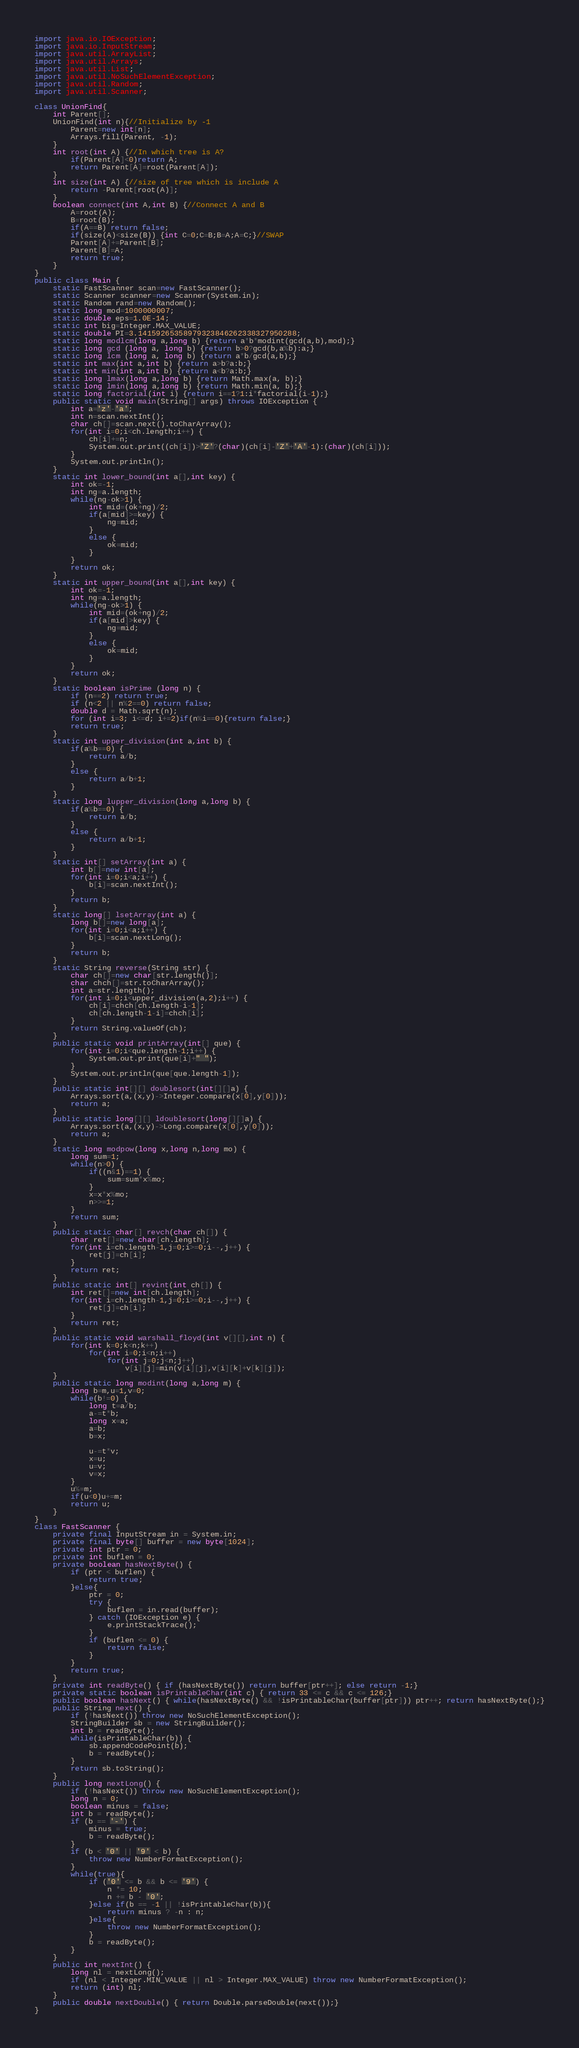<code> <loc_0><loc_0><loc_500><loc_500><_Java_>import java.io.IOException;
import java.io.InputStream;
import java.util.ArrayList;
import java.util.Arrays;
import java.util.List;
import java.util.NoSuchElementException;
import java.util.Random;
import java.util.Scanner;

class UnionFind{
	int Parent[];
	UnionFind(int n){//Initialize by -1
		Parent=new int[n];
		Arrays.fill(Parent, -1);
	}
	int root(int A) {//In which tree is A?
		if(Parent[A]<0)return A;
		return Parent[A]=root(Parent[A]);
	}
	int size(int A) {//size of tree which is include A
		return -Parent[root(A)];
	}
	boolean connect(int A,int B) {//Connect A and B
		A=root(A);
		B=root(B);
		if(A==B) return false;
		if(size(A)<size(B)) {int C=0;C=B;B=A;A=C;}//SWAP
		Parent[A]+=Parent[B];
		Parent[B]=A;
		return true;
	}
}
public class Main {
	static FastScanner scan=new FastScanner();
	static Scanner scanner=new Scanner(System.in);
	static Random rand=new Random();
	static long mod=1000000007;
	static double eps=1.0E-14;
	static int big=Integer.MAX_VALUE;
	static double PI=3.14159265358979323846262338327950288;
	static long modlcm(long a,long b) {return a*b*modint(gcd(a,b),mod);}
	static long gcd (long a, long b) {return b>0?gcd(b,a%b):a;}
	static long lcm (long a, long b) {return a*b/gcd(a,b);}
	static int max(int a,int b) {return a>b?a:b;}
	static int min(int a,int b) {return a<b?a:b;}
	static long lmax(long a,long b) {return Math.max(a, b);}
	static long lmin(long a,long b) {return Math.min(a, b);}
	static long factorial(int i) {return i==1?1:i*factorial(i-1);}
	public static void main(String[] args) throws IOException {
		int a='z'-'a';
		int n=scan.nextInt();
		char ch[]=scan.next().toCharArray();
		for(int i=0;i<ch.length;i++) {
			ch[i]+=n;
			System.out.print((ch[i])>'Z'?(char)(ch[i]-'Z'+'A'-1):(char)(ch[i]));
		}
		System.out.println();
	}
	static int lower_bound(int a[],int key) {
		int ok=-1;
		int ng=a.length;
		while(ng-ok>1) {
			int mid=(ok+ng)/2;
			if(a[mid]>=key) {
				ng=mid;
			}
			else {
				ok=mid;
			}
		}
		return ok;
	}
	static int upper_bound(int a[],int key) {
		int ok=-1;
		int ng=a.length;
		while(ng-ok>1) {
			int mid=(ok+ng)/2;
			if(a[mid]>key) {
				ng=mid;
			}
			else {
				ok=mid;
			}
		}
		return ok;
	}
	static boolean isPrime (long n) {
		if (n==2) return true;
		if (n<2 || n%2==0) return false;
		double d = Math.sqrt(n);
		for (int i=3; i<=d; i+=2)if(n%i==0){return false;}
		return true;
	}
	static int upper_division(int a,int b) {
		if(a%b==0) {
			return a/b;
		}
		else {
			return a/b+1;
		}
	}
	static long lupper_division(long a,long b) {
		if(a%b==0) {
			return a/b;
		}
		else {
			return a/b+1;
		}
	}
	static int[] setArray(int a) {
		int b[]=new int[a];
		for(int i=0;i<a;i++) {
			b[i]=scan.nextInt();
		}
		return b;
	}
	static long[] lsetArray(int a) {
		long b[]=new long[a];
		for(int i=0;i<a;i++) {
			b[i]=scan.nextLong();
		}
		return b;
	}
	static String reverse(String str) {
		char ch[]=new char[str.length()];
		char chch[]=str.toCharArray();
		int a=str.length();
		for(int i=0;i<upper_division(a,2);i++) {
			ch[i]=chch[ch.length-i-1];
			ch[ch.length-1-i]=chch[i];
		}
		return String.valueOf(ch);
	}
	public static void printArray(int[] que) {
		for(int i=0;i<que.length-1;i++) {
			System.out.print(que[i]+" ");
		}
		System.out.println(que[que.length-1]);
	}
	public static int[][] doublesort(int[][]a) {
		Arrays.sort(a,(x,y)->Integer.compare(x[0],y[0]));
		return a;
	}
	public static long[][] ldoublesort(long[][]a) {
		Arrays.sort(a,(x,y)->Long.compare(x[0],y[0]));
		return a;
	}
	static long modpow(long x,long n,long mo) {
		long sum=1;
		while(n>0) {
			if((n&1)==1) {
				sum=sum*x%mo;
			}
			x=x*x%mo;
			n>>=1;
		}
		return sum;
	}
	public static char[] revch(char ch[]) {
		char ret[]=new char[ch.length];
		for(int i=ch.length-1,j=0;i>=0;i--,j++) {
			ret[j]=ch[i];
		}
		return ret;
	}
	public static int[] revint(int ch[]) {
		int ret[]=new int[ch.length];
		for(int i=ch.length-1,j=0;i>=0;i--,j++) {
			ret[j]=ch[i];
		}
		return ret;
	}
	public static void warshall_floyd(int v[][],int n) {
		for(int k=0;k<n;k++)
			for(int i=0;i<n;i++)
				for(int j=0;j<n;j++)
					v[i][j]=min(v[i][j],v[i][k]+v[k][j]);
	}
	public static long modint(long a,long m) {
		long b=m,u=1,v=0;
		while(b!=0) {
			long t=a/b;
			a-=t*b;
			long x=a;
			a=b;
			b=x;

			u-=t*v;
			x=u;
			u=v;
			v=x;
		}
		u%=m;
		if(u<0)u+=m;
		return u;
	}
}
class FastScanner {
	private final InputStream in = System.in;
	private final byte[] buffer = new byte[1024];
	private int ptr = 0;
	private int buflen = 0;
	private boolean hasNextByte() {
		if (ptr < buflen) {
			return true;
		}else{
			ptr = 0;
			try {
				buflen = in.read(buffer);
			} catch (IOException e) {
				e.printStackTrace();
			}
			if (buflen <= 0) {
				return false;
			}
		}
		return true;
	}
	private int readByte() { if (hasNextByte()) return buffer[ptr++]; else return -1;}
	private static boolean isPrintableChar(int c) { return 33 <= c && c <= 126;}
	public boolean hasNext() { while(hasNextByte() && !isPrintableChar(buffer[ptr])) ptr++; return hasNextByte();}
	public String next() {
		if (!hasNext()) throw new NoSuchElementException();
		StringBuilder sb = new StringBuilder();
		int b = readByte();
		while(isPrintableChar(b)) {
			sb.appendCodePoint(b);
			b = readByte();
		}
		return sb.toString();
	}
	public long nextLong() {
		if (!hasNext()) throw new NoSuchElementException();
		long n = 0;
		boolean minus = false;
		int b = readByte();
		if (b == '-') {
			minus = true;
			b = readByte();
		}
		if (b < '0' || '9' < b) {
			throw new NumberFormatException();
		}
		while(true){
			if ('0' <= b && b <= '9') {
				n *= 10;
				n += b - '0';
			}else if(b == -1 || !isPrintableChar(b)){
				return minus ? -n : n;
			}else{
				throw new NumberFormatException();
			}
			b = readByte();
		}
	}
	public int nextInt() {
		long nl = nextLong();
		if (nl < Integer.MIN_VALUE || nl > Integer.MAX_VALUE) throw new NumberFormatException();
		return (int) nl;
	}
	public double nextDouble() { return Double.parseDouble(next());}
}
</code> 